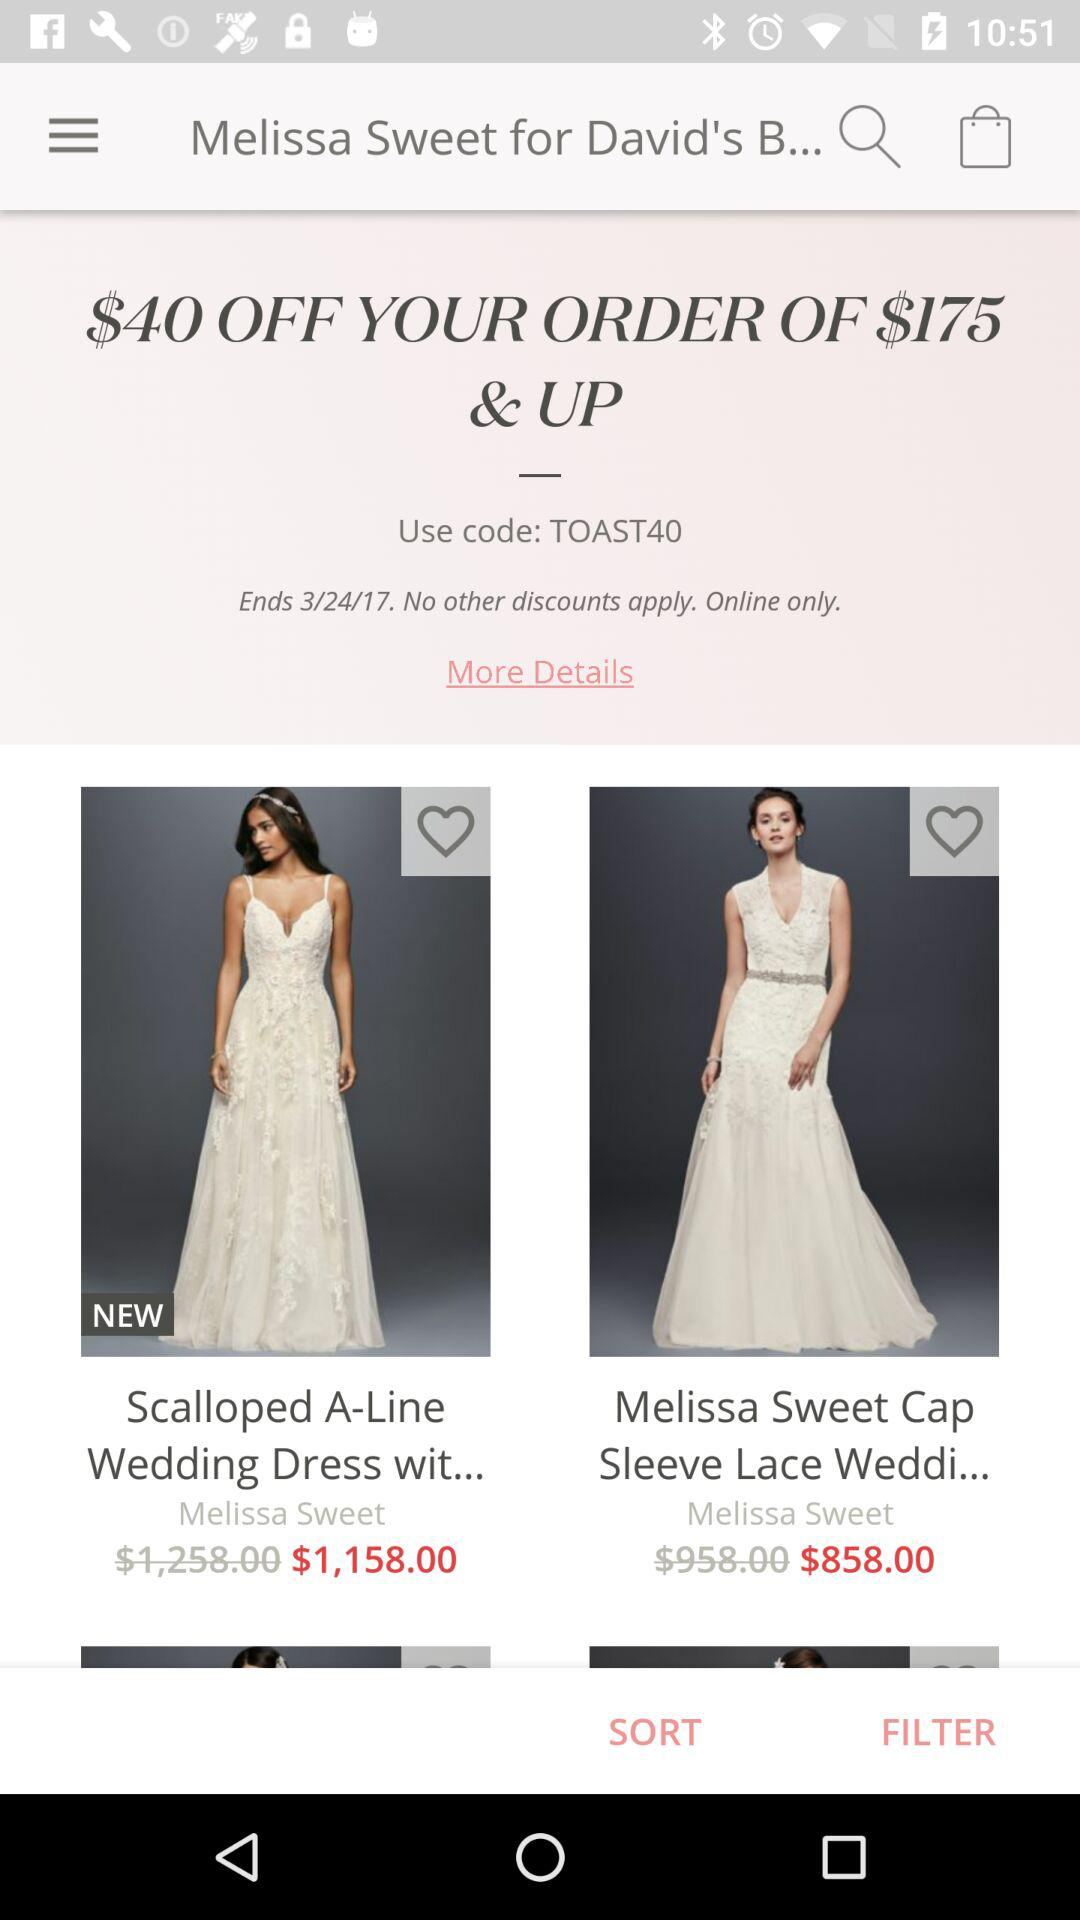Which dresses are marked as liked?
When the provided information is insufficient, respond with <no answer>. <no answer> 